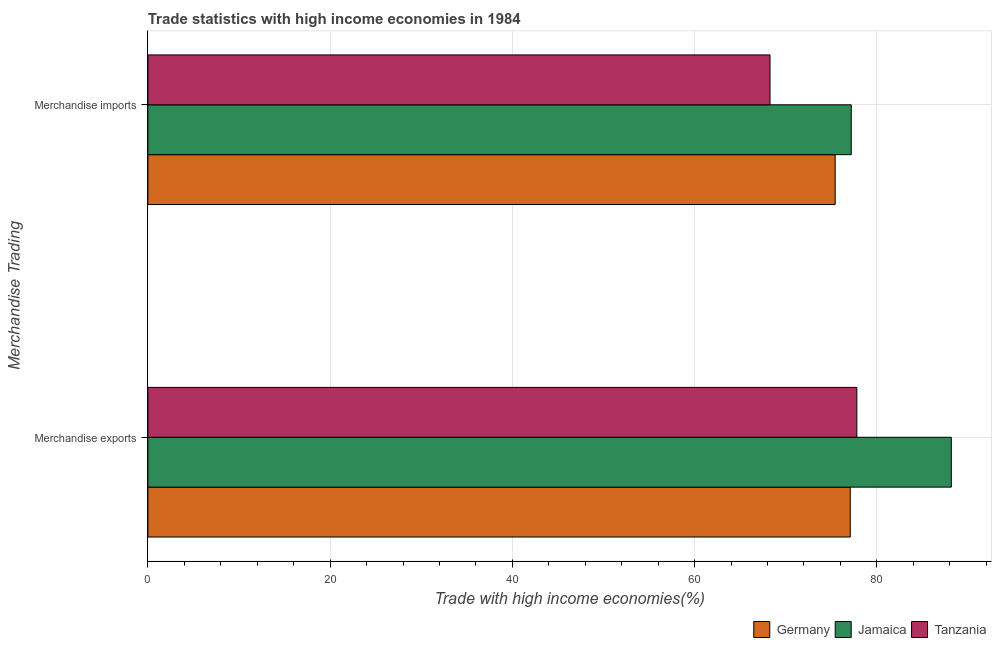How many groups of bars are there?
Offer a terse response. 2. Are the number of bars on each tick of the Y-axis equal?
Make the answer very short. Yes. How many bars are there on the 2nd tick from the bottom?
Ensure brevity in your answer.  3. What is the label of the 2nd group of bars from the top?
Make the answer very short. Merchandise exports. What is the merchandise exports in Jamaica?
Ensure brevity in your answer.  88.17. Across all countries, what is the maximum merchandise imports?
Provide a short and direct response. 77.19. Across all countries, what is the minimum merchandise imports?
Make the answer very short. 68.28. In which country was the merchandise exports maximum?
Ensure brevity in your answer.  Jamaica. In which country was the merchandise imports minimum?
Offer a terse response. Tanzania. What is the total merchandise imports in the graph?
Provide a succinct answer. 220.9. What is the difference between the merchandise exports in Tanzania and that in Germany?
Provide a succinct answer. 0.72. What is the difference between the merchandise imports in Tanzania and the merchandise exports in Germany?
Ensure brevity in your answer.  -8.81. What is the average merchandise imports per country?
Give a very brief answer. 73.63. What is the difference between the merchandise exports and merchandise imports in Germany?
Your answer should be compact. 1.66. What is the ratio of the merchandise imports in Tanzania to that in Germany?
Keep it short and to the point. 0.91. Is the merchandise exports in Jamaica less than that in Germany?
Your answer should be very brief. No. What does the 1st bar from the top in Merchandise imports represents?
Make the answer very short. Tanzania. What does the 3rd bar from the bottom in Merchandise exports represents?
Your answer should be compact. Tanzania. Are all the bars in the graph horizontal?
Your answer should be very brief. Yes. Does the graph contain grids?
Your response must be concise. Yes. How many legend labels are there?
Ensure brevity in your answer.  3. What is the title of the graph?
Ensure brevity in your answer.  Trade statistics with high income economies in 1984. Does "Djibouti" appear as one of the legend labels in the graph?
Provide a succinct answer. No. What is the label or title of the X-axis?
Offer a very short reply. Trade with high income economies(%). What is the label or title of the Y-axis?
Give a very brief answer. Merchandise Trading. What is the Trade with high income economies(%) in Germany in Merchandise exports?
Give a very brief answer. 77.08. What is the Trade with high income economies(%) in Jamaica in Merchandise exports?
Provide a short and direct response. 88.17. What is the Trade with high income economies(%) in Tanzania in Merchandise exports?
Offer a very short reply. 77.81. What is the Trade with high income economies(%) of Germany in Merchandise imports?
Offer a very short reply. 75.43. What is the Trade with high income economies(%) of Jamaica in Merchandise imports?
Your answer should be compact. 77.19. What is the Trade with high income economies(%) of Tanzania in Merchandise imports?
Your answer should be very brief. 68.28. Across all Merchandise Trading, what is the maximum Trade with high income economies(%) of Germany?
Your response must be concise. 77.08. Across all Merchandise Trading, what is the maximum Trade with high income economies(%) in Jamaica?
Provide a succinct answer. 88.17. Across all Merchandise Trading, what is the maximum Trade with high income economies(%) in Tanzania?
Keep it short and to the point. 77.81. Across all Merchandise Trading, what is the minimum Trade with high income economies(%) in Germany?
Ensure brevity in your answer.  75.43. Across all Merchandise Trading, what is the minimum Trade with high income economies(%) in Jamaica?
Offer a very short reply. 77.19. Across all Merchandise Trading, what is the minimum Trade with high income economies(%) in Tanzania?
Make the answer very short. 68.28. What is the total Trade with high income economies(%) of Germany in the graph?
Your answer should be compact. 152.51. What is the total Trade with high income economies(%) in Jamaica in the graph?
Give a very brief answer. 165.37. What is the total Trade with high income economies(%) of Tanzania in the graph?
Ensure brevity in your answer.  146.08. What is the difference between the Trade with high income economies(%) in Germany in Merchandise exports and that in Merchandise imports?
Your answer should be very brief. 1.66. What is the difference between the Trade with high income economies(%) in Jamaica in Merchandise exports and that in Merchandise imports?
Provide a succinct answer. 10.98. What is the difference between the Trade with high income economies(%) in Tanzania in Merchandise exports and that in Merchandise imports?
Ensure brevity in your answer.  9.53. What is the difference between the Trade with high income economies(%) of Germany in Merchandise exports and the Trade with high income economies(%) of Jamaica in Merchandise imports?
Give a very brief answer. -0.11. What is the difference between the Trade with high income economies(%) of Germany in Merchandise exports and the Trade with high income economies(%) of Tanzania in Merchandise imports?
Offer a very short reply. 8.81. What is the difference between the Trade with high income economies(%) in Jamaica in Merchandise exports and the Trade with high income economies(%) in Tanzania in Merchandise imports?
Offer a very short reply. 19.9. What is the average Trade with high income economies(%) in Germany per Merchandise Trading?
Offer a very short reply. 76.26. What is the average Trade with high income economies(%) in Jamaica per Merchandise Trading?
Ensure brevity in your answer.  82.68. What is the average Trade with high income economies(%) in Tanzania per Merchandise Trading?
Your answer should be compact. 73.04. What is the difference between the Trade with high income economies(%) of Germany and Trade with high income economies(%) of Jamaica in Merchandise exports?
Give a very brief answer. -11.09. What is the difference between the Trade with high income economies(%) in Germany and Trade with high income economies(%) in Tanzania in Merchandise exports?
Your response must be concise. -0.72. What is the difference between the Trade with high income economies(%) in Jamaica and Trade with high income economies(%) in Tanzania in Merchandise exports?
Offer a terse response. 10.37. What is the difference between the Trade with high income economies(%) of Germany and Trade with high income economies(%) of Jamaica in Merchandise imports?
Offer a very short reply. -1.77. What is the difference between the Trade with high income economies(%) in Germany and Trade with high income economies(%) in Tanzania in Merchandise imports?
Give a very brief answer. 7.15. What is the difference between the Trade with high income economies(%) of Jamaica and Trade with high income economies(%) of Tanzania in Merchandise imports?
Provide a short and direct response. 8.92. What is the ratio of the Trade with high income economies(%) of Germany in Merchandise exports to that in Merchandise imports?
Offer a very short reply. 1.02. What is the ratio of the Trade with high income economies(%) in Jamaica in Merchandise exports to that in Merchandise imports?
Your answer should be compact. 1.14. What is the ratio of the Trade with high income economies(%) of Tanzania in Merchandise exports to that in Merchandise imports?
Provide a succinct answer. 1.14. What is the difference between the highest and the second highest Trade with high income economies(%) in Germany?
Keep it short and to the point. 1.66. What is the difference between the highest and the second highest Trade with high income economies(%) in Jamaica?
Provide a succinct answer. 10.98. What is the difference between the highest and the second highest Trade with high income economies(%) of Tanzania?
Give a very brief answer. 9.53. What is the difference between the highest and the lowest Trade with high income economies(%) in Germany?
Keep it short and to the point. 1.66. What is the difference between the highest and the lowest Trade with high income economies(%) in Jamaica?
Your response must be concise. 10.98. What is the difference between the highest and the lowest Trade with high income economies(%) in Tanzania?
Your response must be concise. 9.53. 